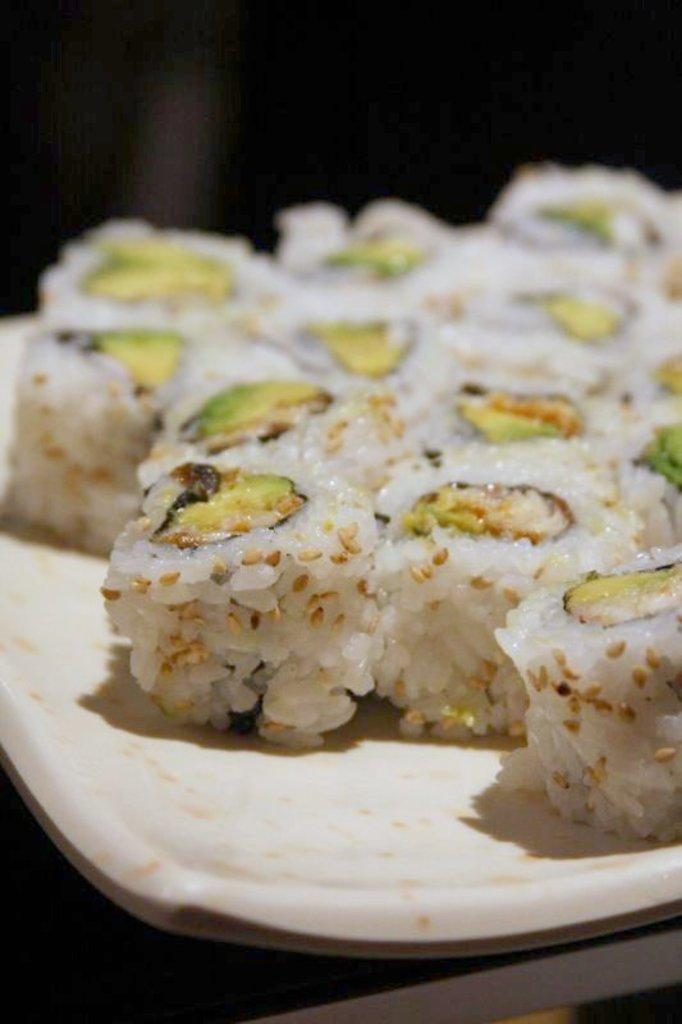What can be seen on the plate in the image? There is a food item on the plate in the image. Can you describe the plate itself? The facts provided do not give any specific details about the plate, so we cannot describe it further. What type of steel is used to make the dog visible in the image? There is no dog present in the image, and therefore no steel can be associated with it. 